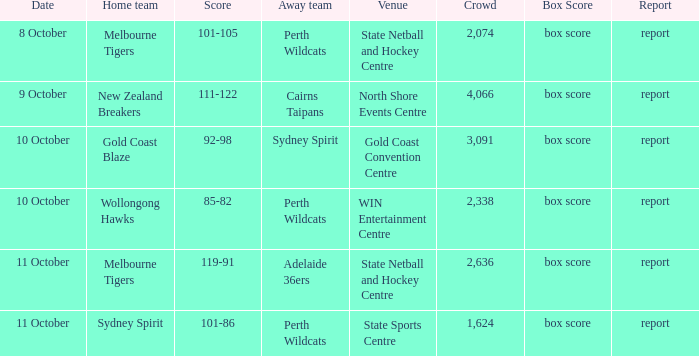What was the average crowd size for the game when the Gold Coast Blaze was the home team? 3091.0. 